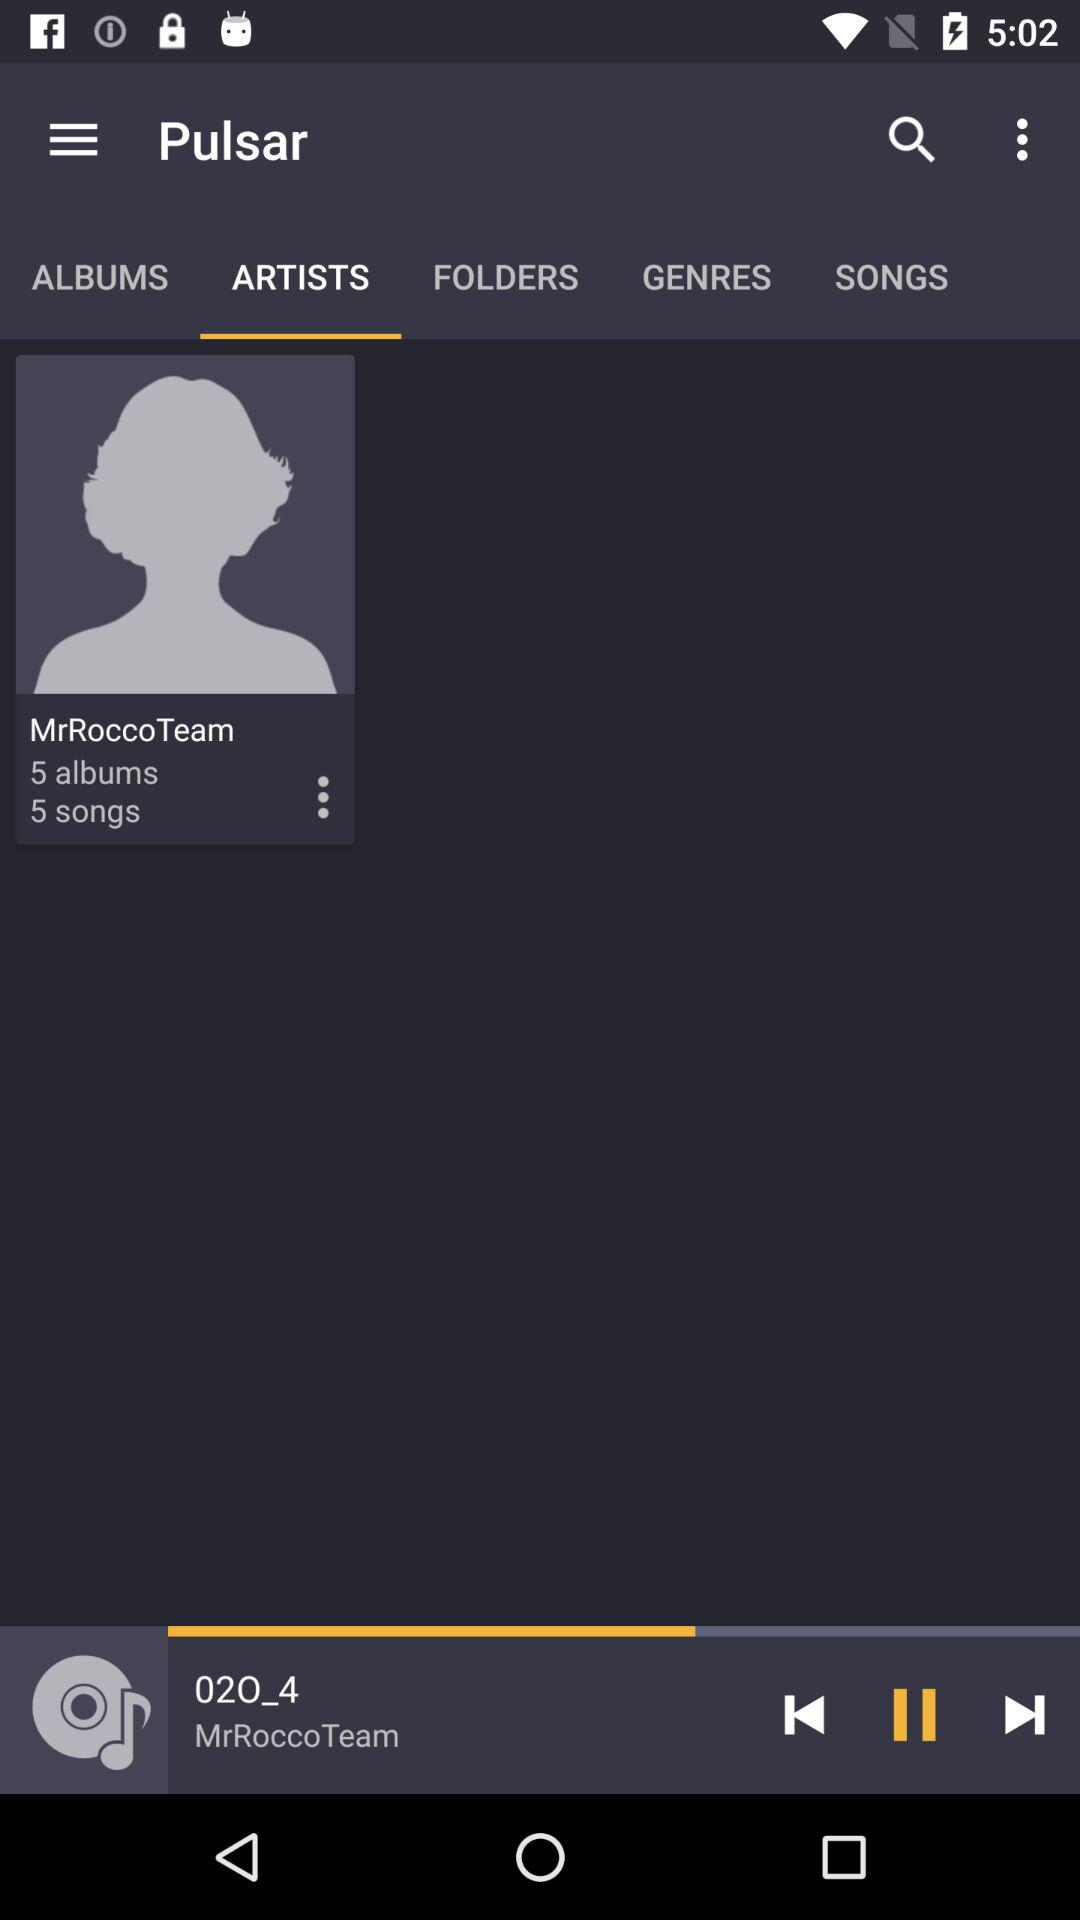How many songs are there by "MrRocooTeam"? There are 5 songs. 